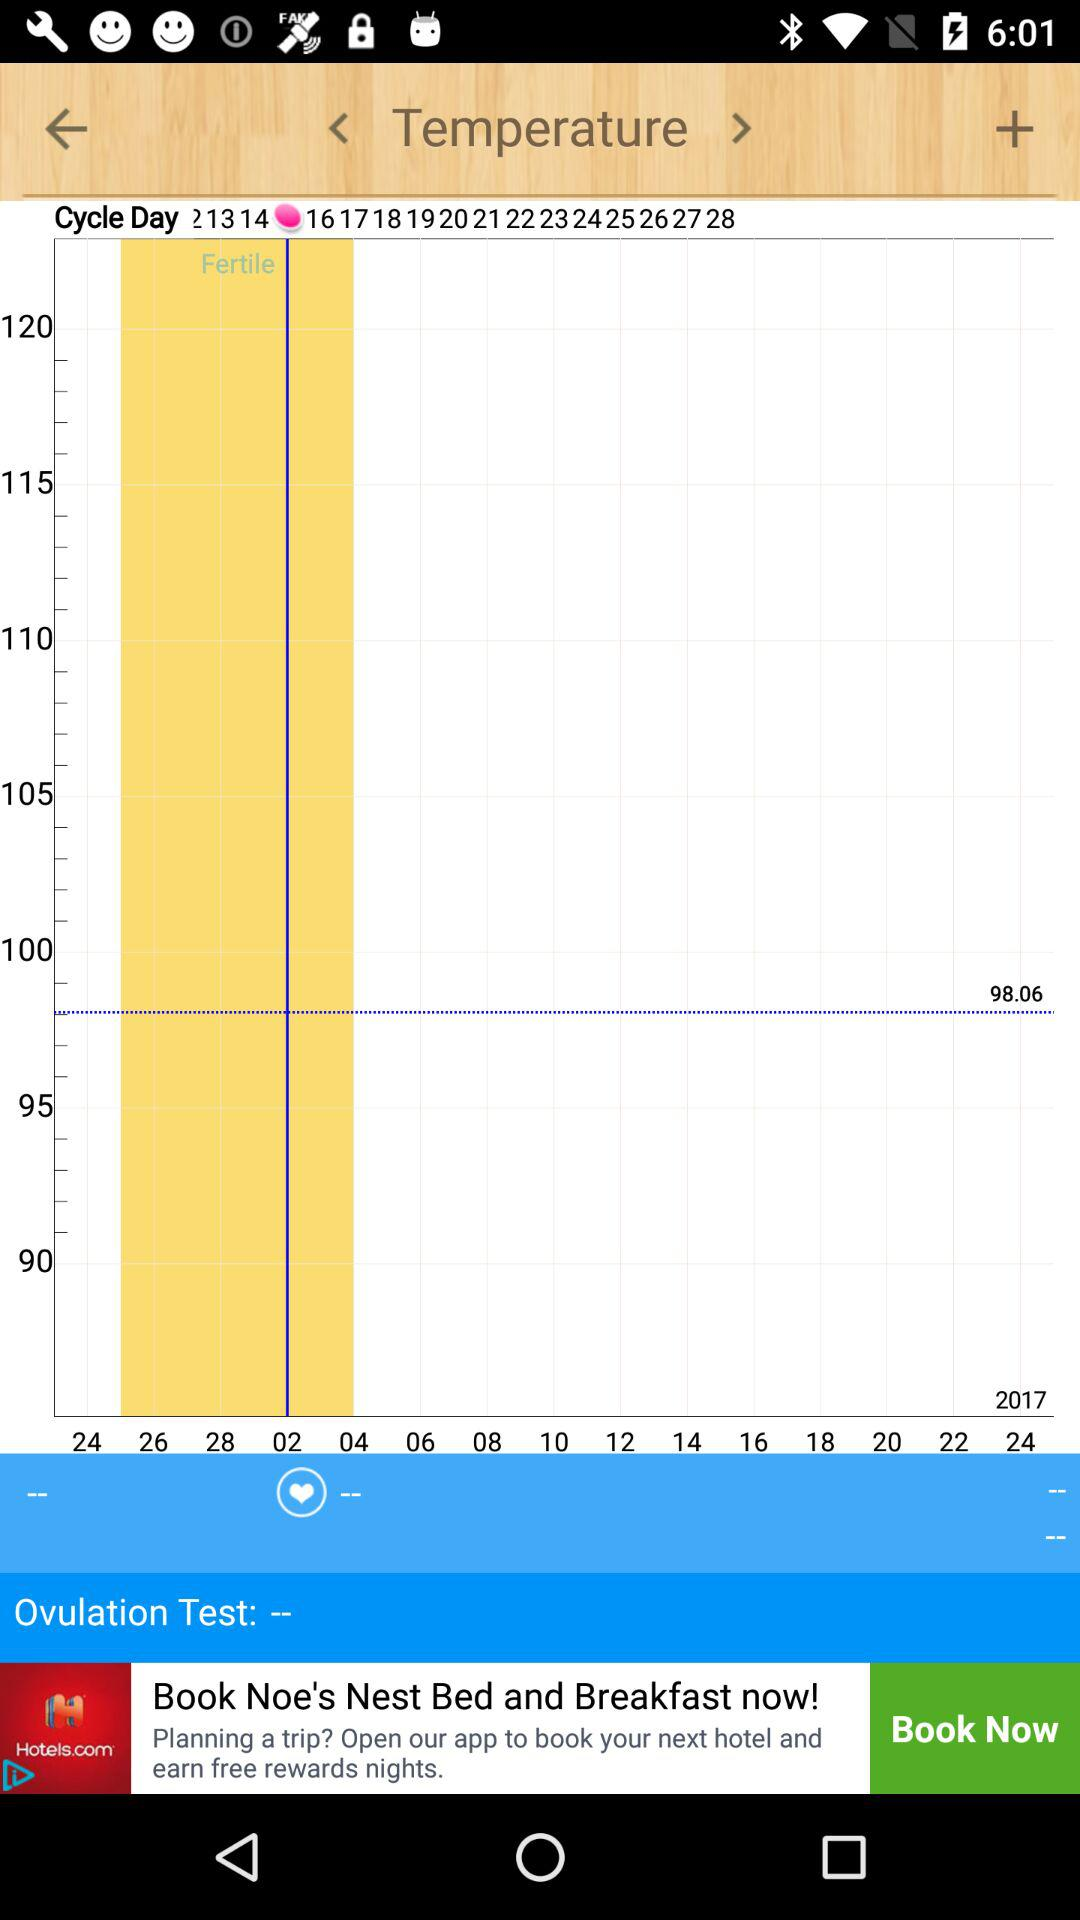How many days are in the user's cycle?
Answer the question using a single word or phrase. 28 